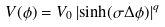<formula> <loc_0><loc_0><loc_500><loc_500>V ( \phi ) = V _ { 0 } \left | \sinh ( \sigma \Delta \phi ) \right | ^ { q }</formula> 